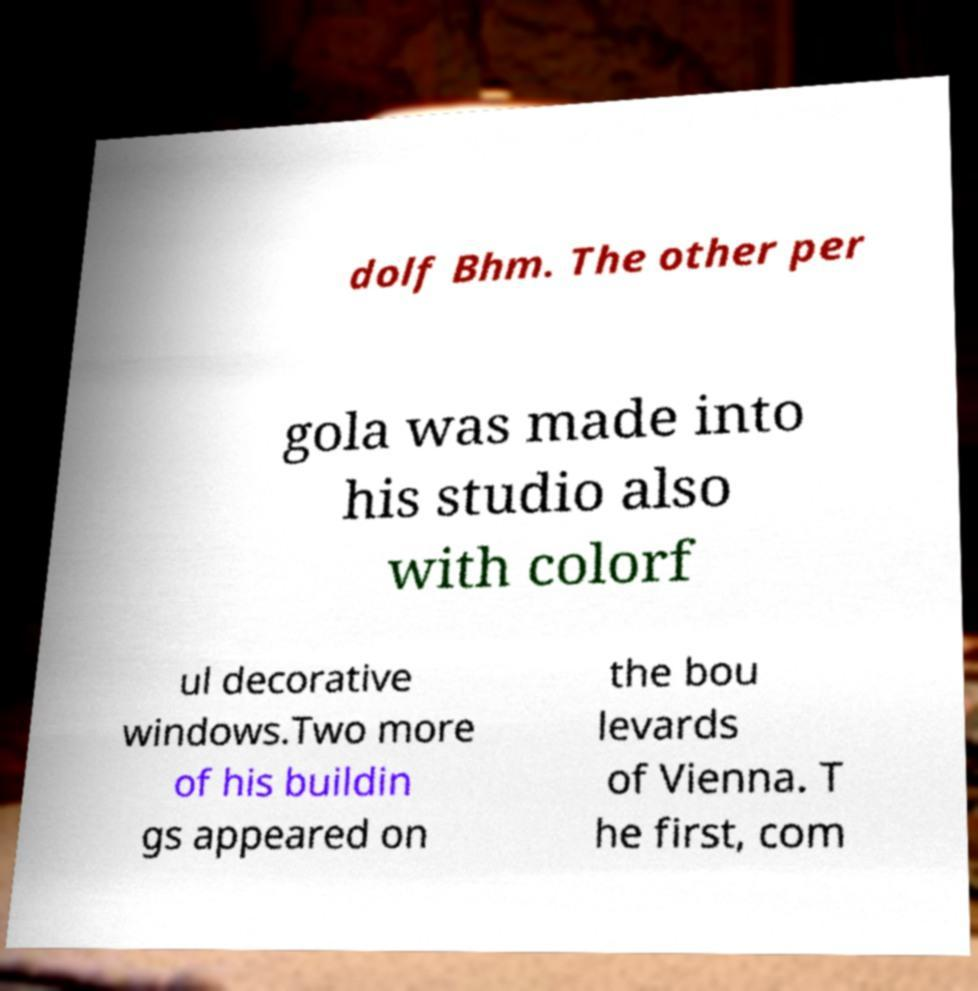What messages or text are displayed in this image? I need them in a readable, typed format. dolf Bhm. The other per gola was made into his studio also with colorf ul decorative windows.Two more of his buildin gs appeared on the bou levards of Vienna. T he first, com 